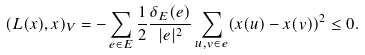Convert formula to latex. <formula><loc_0><loc_0><loc_500><loc_500>( L ( x ) , x ) _ { V } = - \sum _ { e \in E } \frac { 1 } { 2 } \frac { \delta _ { E } ( e ) } { | e | ^ { 2 } } \sum _ { u , v \in e } ( x ( u ) - x ( v ) ) ^ { 2 } \leq 0 .</formula> 